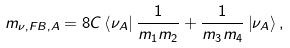Convert formula to latex. <formula><loc_0><loc_0><loc_500><loc_500>m _ { \nu , F B , A } = 8 C \left \langle { \nu _ { A } } \right | { \frac { 1 } { m _ { 1 } m _ { 2 } } + \frac { 1 } { m _ { 3 } m _ { 4 } } } \left | { \nu _ { A } } \right \rangle ,</formula> 